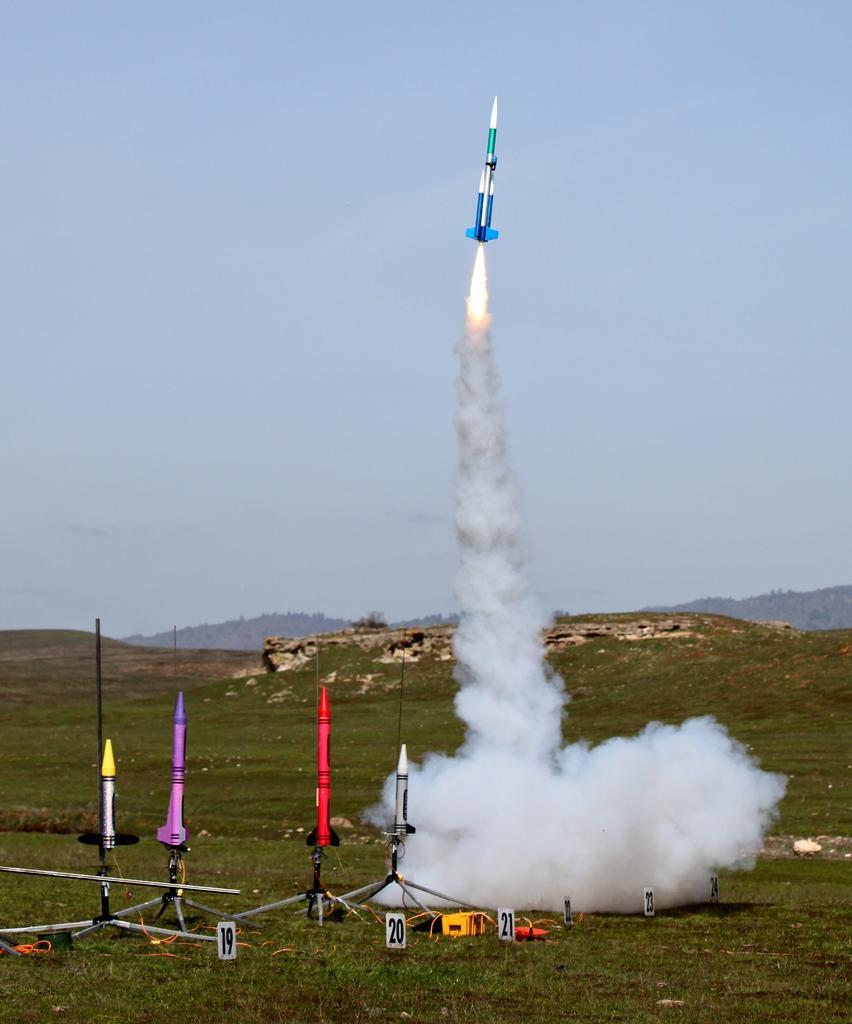Describe this image in one or two sentences. At the bottom of the picture, we see the missiles or the rockets in white, pink and red color. We even see the grass and boards in white color with numbers written on it. There are hills and trees in the background. At the top, we see the sky and the missile is launched. We see the smoke emitted from the missile. 